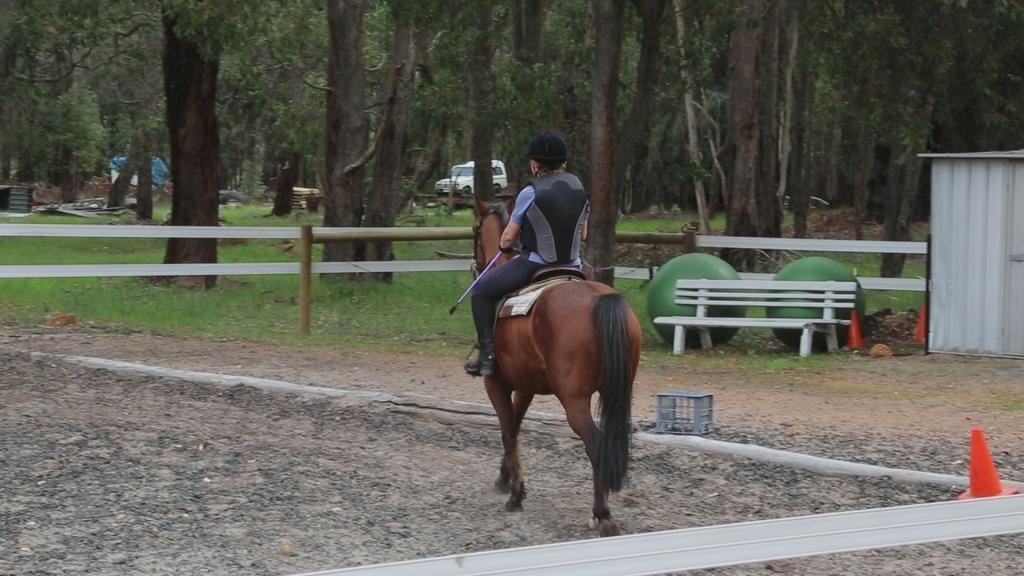Can you describe this image briefly? This is a person sitting and riding the horse. This is a bench. These look like big balls which are green in color. At background I can see a jeep which is white in color. These are the trees. This is a wooden fence. 